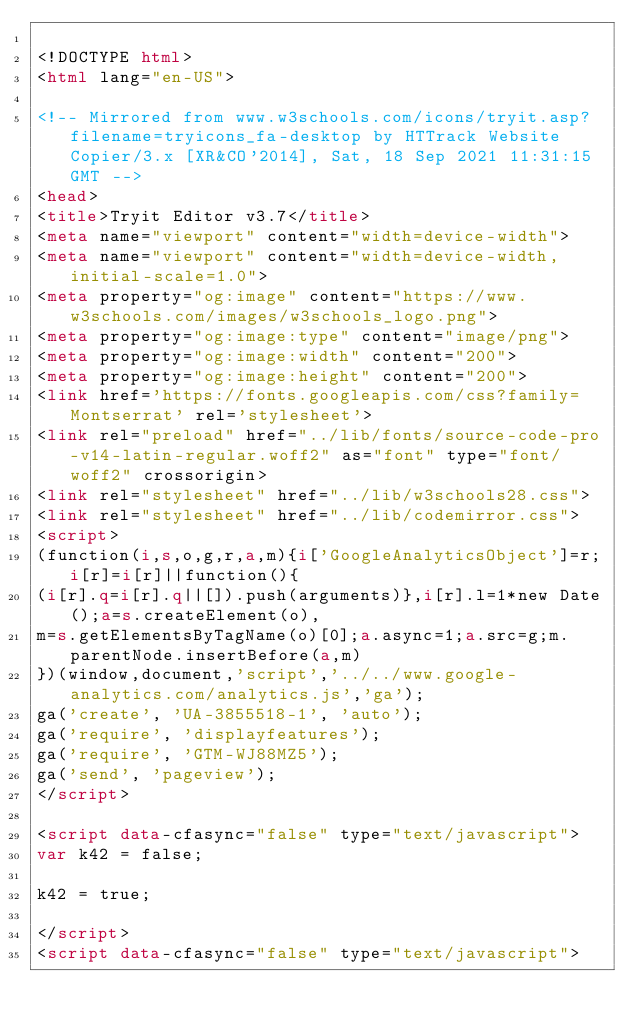<code> <loc_0><loc_0><loc_500><loc_500><_HTML_>
<!DOCTYPE html>
<html lang="en-US">

<!-- Mirrored from www.w3schools.com/icons/tryit.asp?filename=tryicons_fa-desktop by HTTrack Website Copier/3.x [XR&CO'2014], Sat, 18 Sep 2021 11:31:15 GMT -->
<head>
<title>Tryit Editor v3.7</title>
<meta name="viewport" content="width=device-width">
<meta name="viewport" content="width=device-width, initial-scale=1.0">
<meta property="og:image" content="https://www.w3schools.com/images/w3schools_logo.png">
<meta property="og:image:type" content="image/png">
<meta property="og:image:width" content="200">
<meta property="og:image:height" content="200">
<link href='https://fonts.googleapis.com/css?family=Montserrat' rel='stylesheet'>
<link rel="preload" href="../lib/fonts/source-code-pro-v14-latin-regular.woff2" as="font" type="font/woff2" crossorigin>
<link rel="stylesheet" href="../lib/w3schools28.css">
<link rel="stylesheet" href="../lib/codemirror.css">
<script>
(function(i,s,o,g,r,a,m){i['GoogleAnalyticsObject']=r;i[r]=i[r]||function(){
(i[r].q=i[r].q||[]).push(arguments)},i[r].l=1*new Date();a=s.createElement(o),
m=s.getElementsByTagName(o)[0];a.async=1;a.src=g;m.parentNode.insertBefore(a,m)
})(window,document,'script','../../www.google-analytics.com/analytics.js','ga');
ga('create', 'UA-3855518-1', 'auto');
ga('require', 'displayfeatures');
ga('require', 'GTM-WJ88MZ5');
ga('send', 'pageview');
</script>

<script data-cfasync="false" type="text/javascript">
var k42 = false;

k42 = true;

</script>
<script data-cfasync="false" type="text/javascript"></code> 